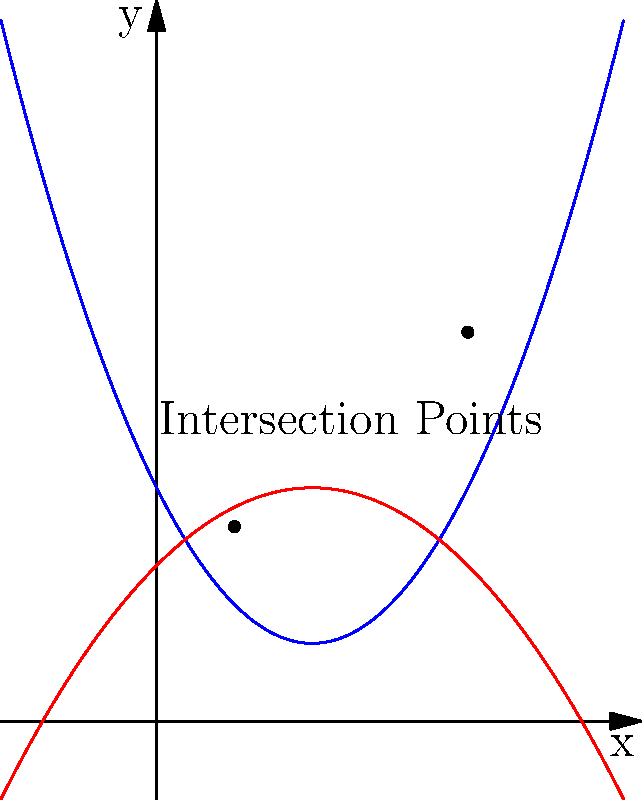In a project risk analysis, two risk factors A and B are represented by polynomial functions:

Risk Factor A: $f_1(x) = 0.5x^2 - 2x + 3$
Risk Factor B: $f_2(x) = -0.25x^2 + x + 2$

Where $x$ represents time in months and $y$ represents the risk level. At which point in time does the project face the highest combined risk (i.e., the maximum y-value of the upper curve at an intersection point)? To solve this problem, we need to follow these steps:

1) Find the intersection points of the two functions:
   $f_1(x) = f_2(x)$
   $0.5x^2 - 2x + 3 = -0.25x^2 + x + 2$
   $0.75x^2 - 3x + 1 = 0$

2) Solve this quadratic equation:
   $x = \frac{3 \pm \sqrt{9 - 4(0.75)(1)}}{2(0.75)}$
   $x = \frac{3 \pm \sqrt{5}}{1.5}$

   This gives us two intersection points:
   $x_1 = 1$ and $x_2 = 4$

3) Calculate the y-values for these points using $f_1(x)$:
   At $x = 1$: $f_1(1) = 0.5(1)^2 - 2(1) + 3 = 2.5$
   At $x = 4$: $f_1(4) = 0.5(4)^2 - 2(4) + 3 = 5$

4) Compare the y-values:
   The higher y-value is 5, which occurs at x = 4.

Therefore, the project faces the highest combined risk at x = 4, which represents 4 months into the project timeline.
Answer: 4 months 